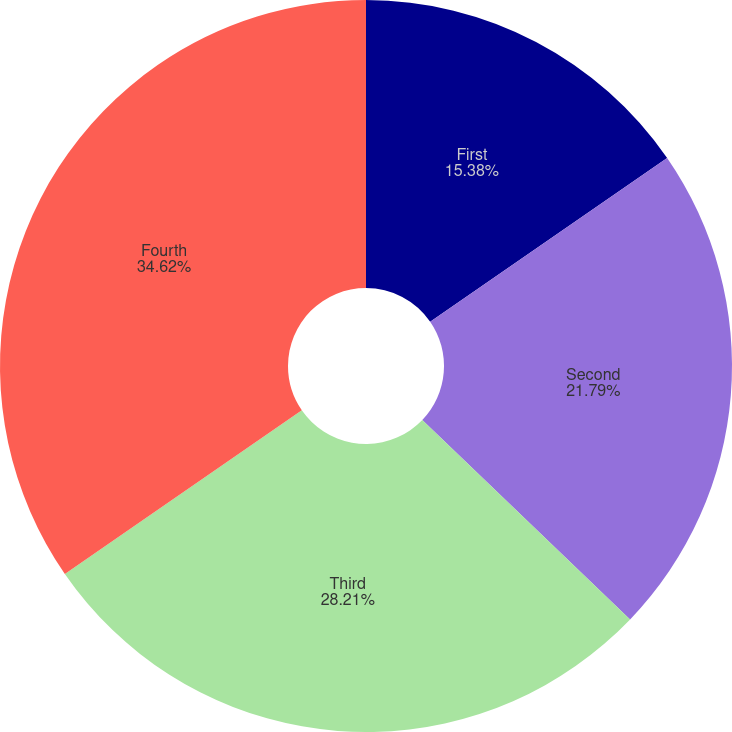Convert chart. <chart><loc_0><loc_0><loc_500><loc_500><pie_chart><fcel>First<fcel>Second<fcel>Third<fcel>Fourth<nl><fcel>15.38%<fcel>21.79%<fcel>28.21%<fcel>34.62%<nl></chart> 